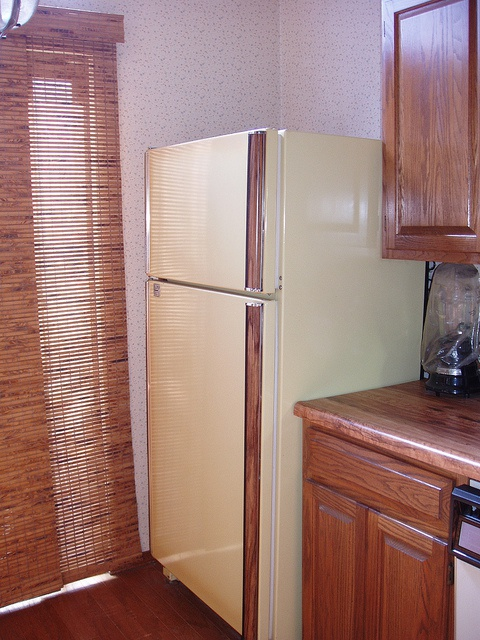Describe the objects in this image and their specific colors. I can see refrigerator in lavender, darkgray, tan, and lightgray tones and oven in lavender, darkgray, black, and maroon tones in this image. 